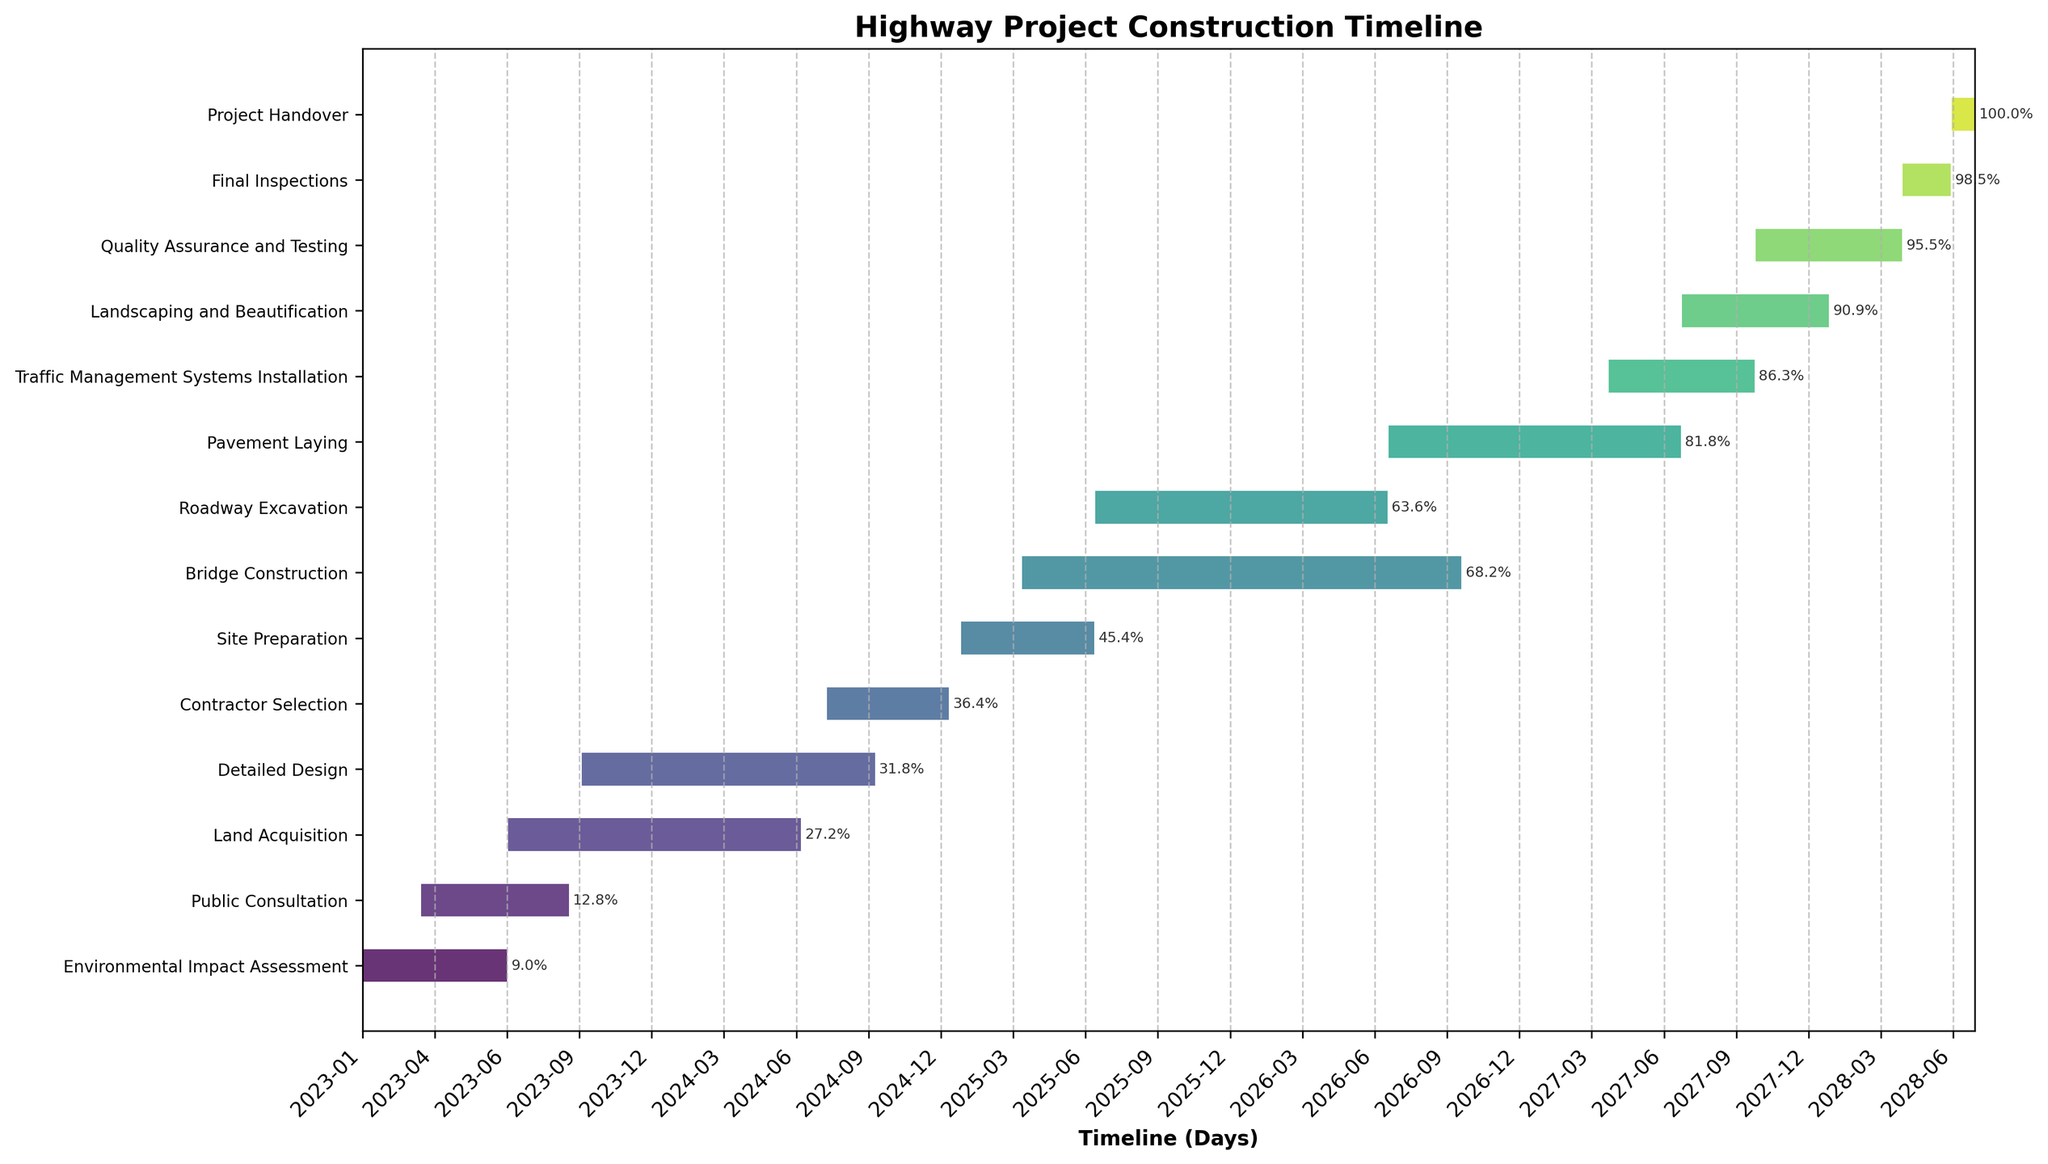Who is responsible for ensuring community feedback is considered in the early stages? The task "Public Consultation" indicates that community feedback is involved in the early stages, starting from March 15, 2023.
Answer: Public Consultation How long does the Environmental Impact Assessment last? The Environmental Impact Assessment starts on January 1, 2023, and ends on June 30, 2023. The duration can be calculated as the difference between the end date and start date.
Answer: 6 months What's the time gap between the completion of "Land Acquisition" and the start of "Site Preparation"? "Land Acquisition" ends on June 30, 2024, and "Site Preparation" starts on January 15, 2025. The time gap is calculated by finding the difference between these dates.
Answer: ~6.5 months Which task has the longest duration, and how long is it? By visual inspection, "Land Acquisition" spans from July 1, 2023, to June 30, 2024, which is the longest among all tasks.
Answer: Land Acquisition, 12 months How does the duration of "Bridge Construction" compare to "Roadway Excavation"? "Bridge Construction" lasts from April 1, 2025, to September 30, 2026 (18 months), while "Roadway Excavation" lasts from July 1, 2025, to June 30, 2026 (12 months). "Bridge Construction" is 6 months longer.
Answer: Bridge Construction is 6 months longer When will the overall completion of the project be, and how long will it take from start to finish? The project starts with the "Environmental Impact Assessment" on January 1, 2023, and ends with the "Project Handover" on June 30, 2028. The total project duration is calculated as the difference from the start date to the end date.
Answer: June 30, 2028; 5.5 years What tasks start within the first six months of the project? Tasks starting within the first six months (by June 30, 2023) are "Environmental Impact Assessment" (January 1, 2023) and "Public Consultation" (March 13, 2023).
Answer: Environmental Impact Assessment, Public Consultation Which tasks are scheduled to run simultaneously in 2027? In 2027, "Pavement Laying," "Traffic Management Systems Installation," "Landscaping and Beautification," "Quality Assurance and Testing," and "Final Inspections" all run simultaneously.
Answer: Pavement Laying, Traffic Management Systems Installation, Landscaping and Beautification, Quality Assurance and Testing, Final Inspections 